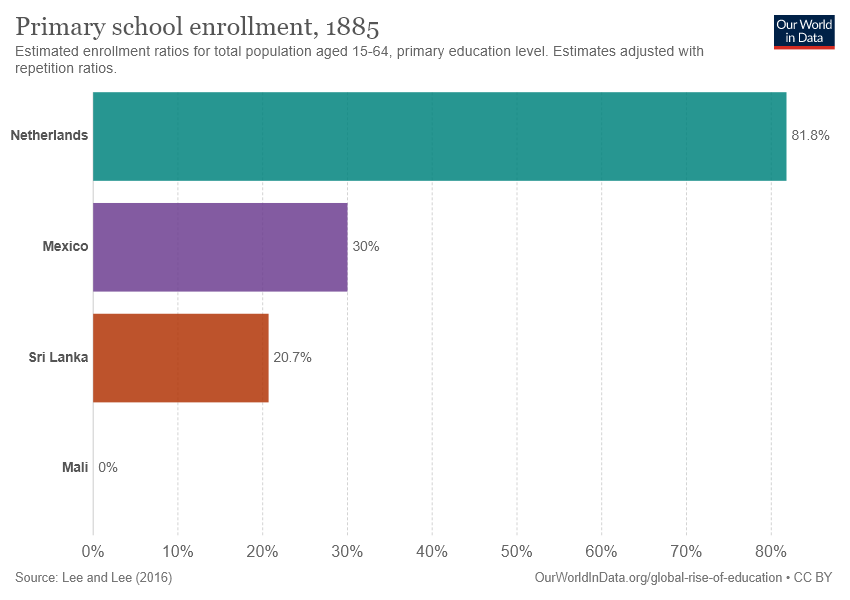Give some essential details in this illustration. Sri Lanka and Mali have a low percentage of primary school enrollment, with less than 25% of their respective populations enrolled in primary school. The difference in the number of primary school enrollment between the Netherlands and Mexico is 0.518. 